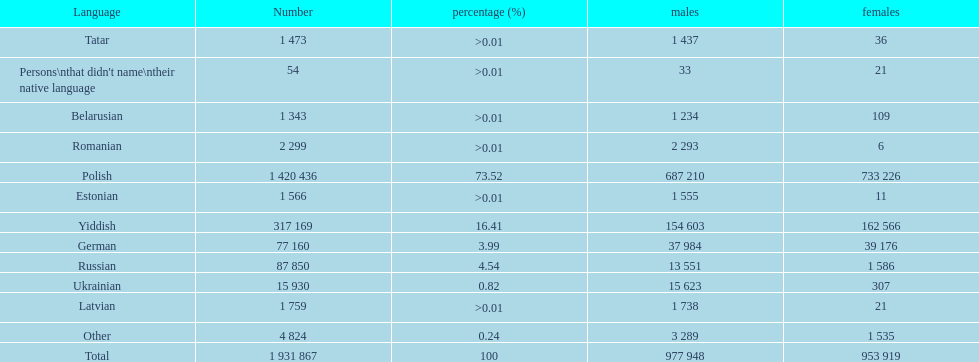What is the highest percentage of speakers other than polish? Yiddish. 